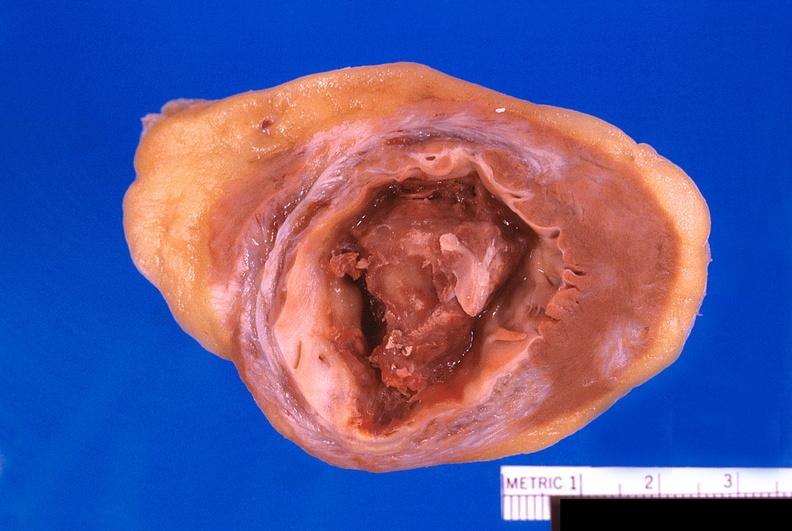does this image show heart, old myocardial infarction with fibrosis and apical thrombus?
Answer the question using a single word or phrase. Yes 